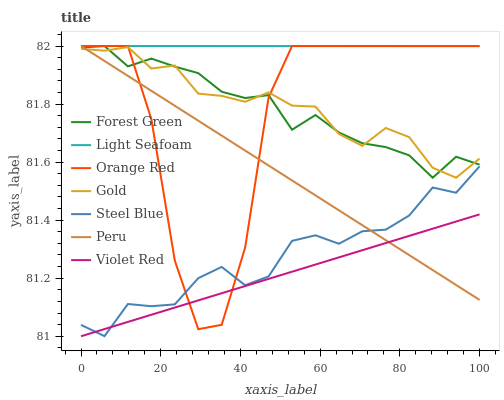Does Violet Red have the minimum area under the curve?
Answer yes or no. Yes. Does Light Seafoam have the maximum area under the curve?
Answer yes or no. Yes. Does Gold have the minimum area under the curve?
Answer yes or no. No. Does Gold have the maximum area under the curve?
Answer yes or no. No. Is Peru the smoothest?
Answer yes or no. Yes. Is Orange Red the roughest?
Answer yes or no. Yes. Is Gold the smoothest?
Answer yes or no. No. Is Gold the roughest?
Answer yes or no. No. Does Violet Red have the lowest value?
Answer yes or no. Yes. Does Gold have the lowest value?
Answer yes or no. No. Does Orange Red have the highest value?
Answer yes or no. Yes. Does Gold have the highest value?
Answer yes or no. No. Is Steel Blue less than Forest Green?
Answer yes or no. Yes. Is Light Seafoam greater than Violet Red?
Answer yes or no. Yes. Does Steel Blue intersect Violet Red?
Answer yes or no. Yes. Is Steel Blue less than Violet Red?
Answer yes or no. No. Is Steel Blue greater than Violet Red?
Answer yes or no. No. Does Steel Blue intersect Forest Green?
Answer yes or no. No. 